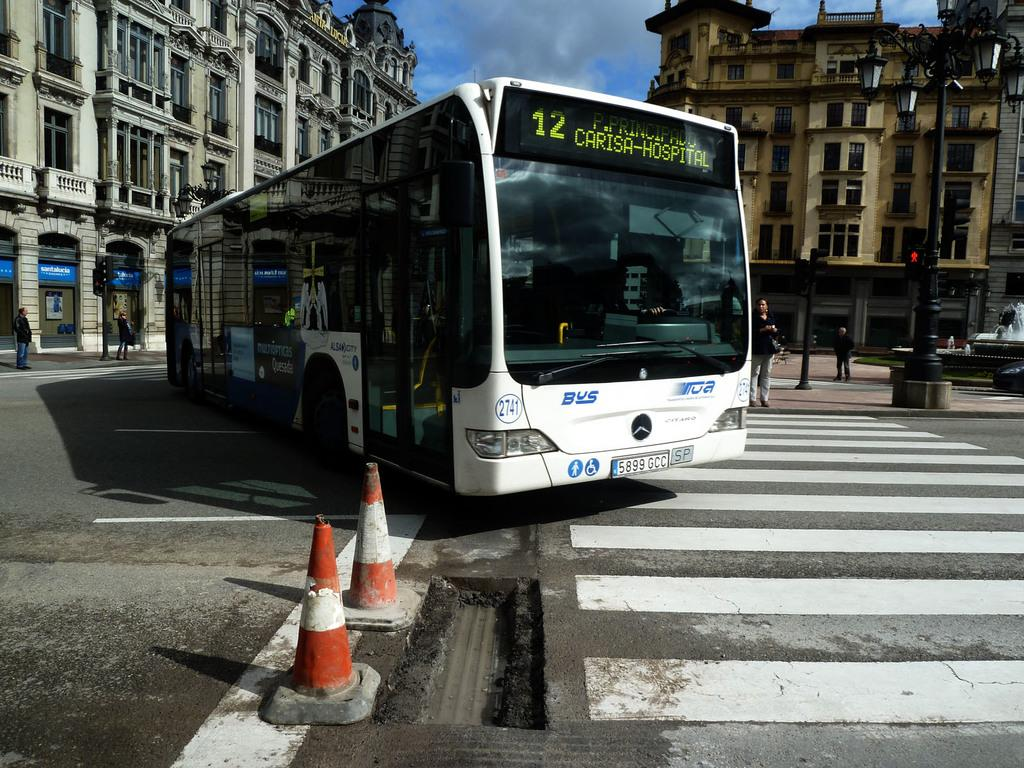<image>
Offer a succinct explanation of the picture presented. number 12 line of carisa-hospital p.principado route bus 